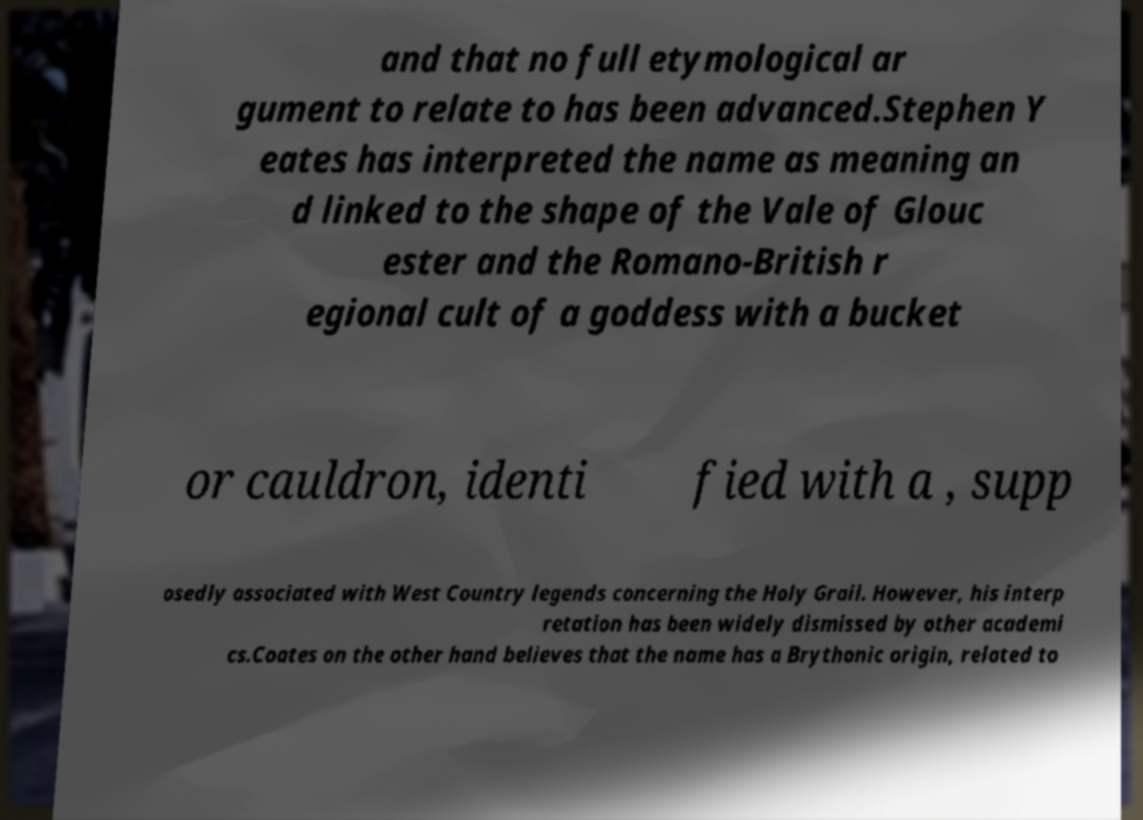Could you extract and type out the text from this image? and that no full etymological ar gument to relate to has been advanced.Stephen Y eates has interpreted the name as meaning an d linked to the shape of the Vale of Glouc ester and the Romano-British r egional cult of a goddess with a bucket or cauldron, identi fied with a , supp osedly associated with West Country legends concerning the Holy Grail. However, his interp retation has been widely dismissed by other academi cs.Coates on the other hand believes that the name has a Brythonic origin, related to 